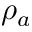<formula> <loc_0><loc_0><loc_500><loc_500>\rho _ { a }</formula> 